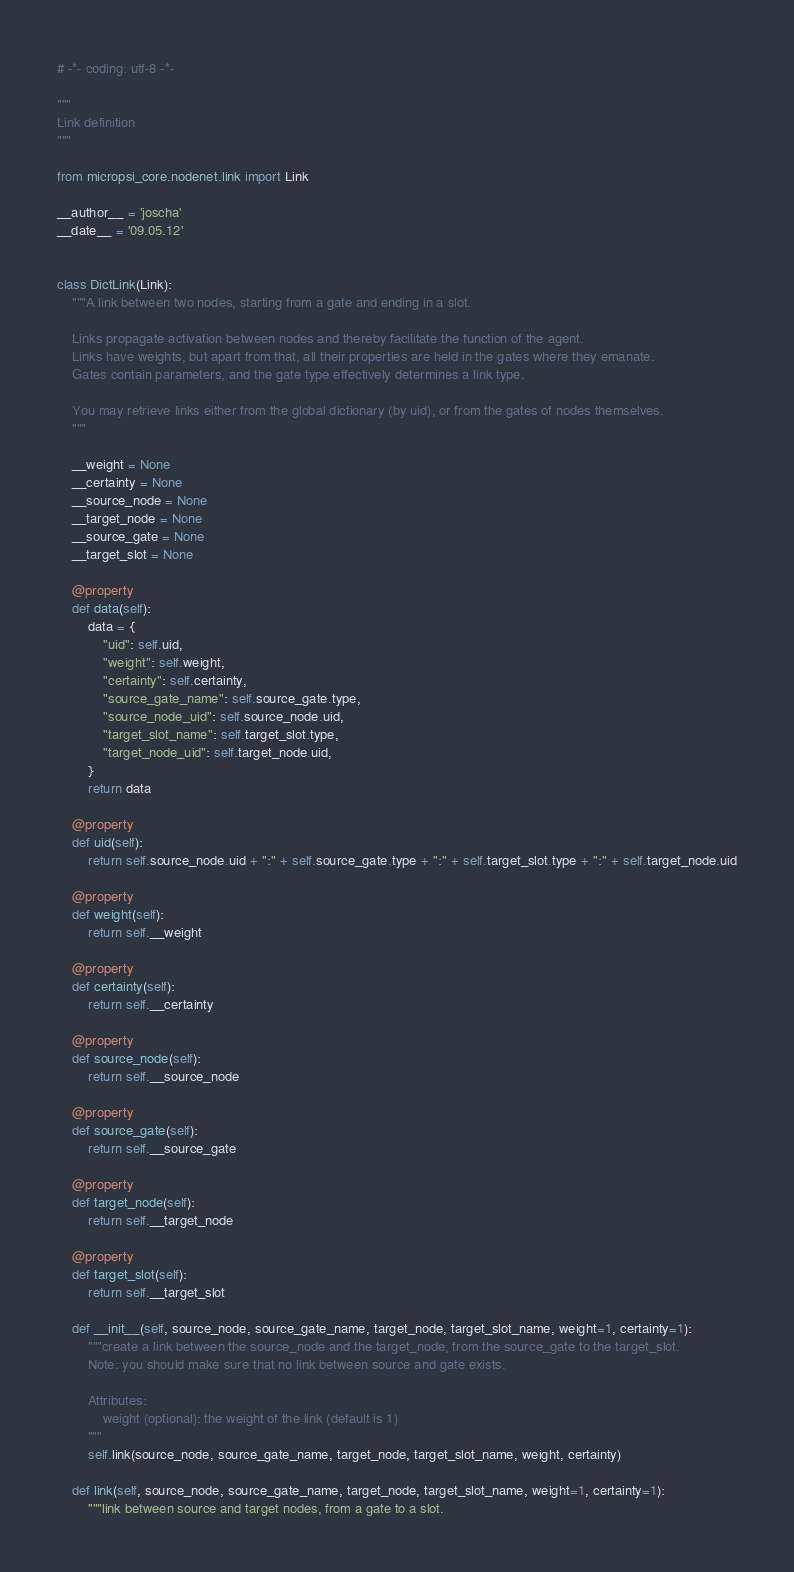<code> <loc_0><loc_0><loc_500><loc_500><_Python_># -*- coding: utf-8 -*-

"""
Link definition
"""

from micropsi_core.nodenet.link import Link

__author__ = 'joscha'
__date__ = '09.05.12'


class DictLink(Link):
    """A link between two nodes, starting from a gate and ending in a slot.

    Links propagate activation between nodes and thereby facilitate the function of the agent.
    Links have weights, but apart from that, all their properties are held in the gates where they emanate.
    Gates contain parameters, and the gate type effectively determines a link type.

    You may retrieve links either from the global dictionary (by uid), or from the gates of nodes themselves.
    """

    __weight = None
    __certainty = None
    __source_node = None
    __target_node = None
    __source_gate = None
    __target_slot = None

    @property
    def data(self):
        data = {
            "uid": self.uid,
            "weight": self.weight,
            "certainty": self.certainty,
            "source_gate_name": self.source_gate.type,
            "source_node_uid": self.source_node.uid,
            "target_slot_name": self.target_slot.type,
            "target_node_uid": self.target_node.uid,
        }
        return data

    @property
    def uid(self):
        return self.source_node.uid + ":" + self.source_gate.type + ":" + self.target_slot.type + ":" + self.target_node.uid

    @property
    def weight(self):
        return self.__weight

    @property
    def certainty(self):
        return self.__certainty

    @property
    def source_node(self):
        return self.__source_node

    @property
    def source_gate(self):
        return self.__source_gate

    @property
    def target_node(self):
        return self.__target_node

    @property
    def target_slot(self):
        return self.__target_slot

    def __init__(self, source_node, source_gate_name, target_node, target_slot_name, weight=1, certainty=1):
        """create a link between the source_node and the target_node, from the source_gate to the target_slot.
        Note: you should make sure that no link between source and gate exists.

        Attributes:
            weight (optional): the weight of the link (default is 1)
        """
        self.link(source_node, source_gate_name, target_node, target_slot_name, weight, certainty)

    def link(self, source_node, source_gate_name, target_node, target_slot_name, weight=1, certainty=1):
        """link between source and target nodes, from a gate to a slot.
</code> 